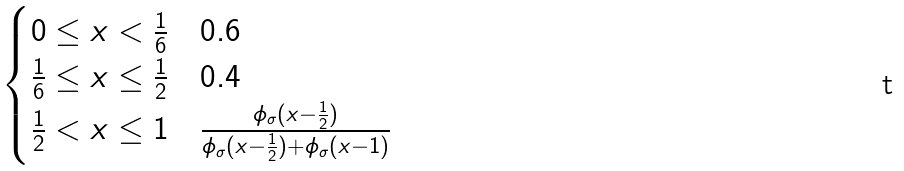<formula> <loc_0><loc_0><loc_500><loc_500>\begin{cases} 0 \leq x < \frac { 1 } { 6 } & 0 . 6 \\ \frac { 1 } { 6 } \leq x \leq \frac { 1 } { 2 } & 0 . 4 \\ \frac { 1 } { 2 } < x \leq 1 & \frac { \phi _ { \sigma } ( x - \frac { 1 } { 2 } ) } { \phi _ { \sigma } ( x - \frac { 1 } { 2 } ) + \phi _ { \sigma } ( x - 1 ) } \end{cases}</formula> 